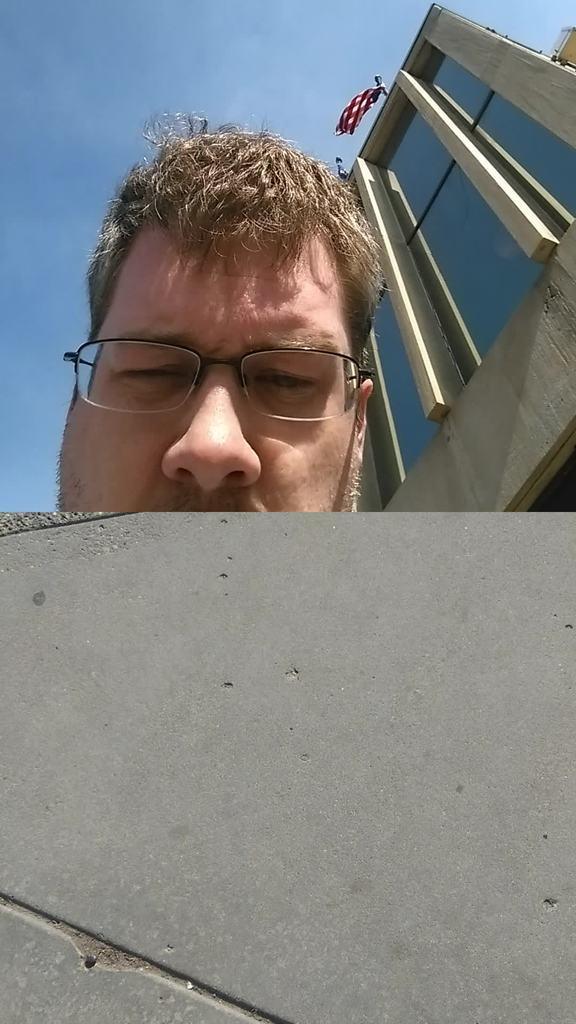Please provide a concise description of this image. In the image there is cement object and behind that a man is hiding his face,the person's face is partially visible and behind the person there is a building. 